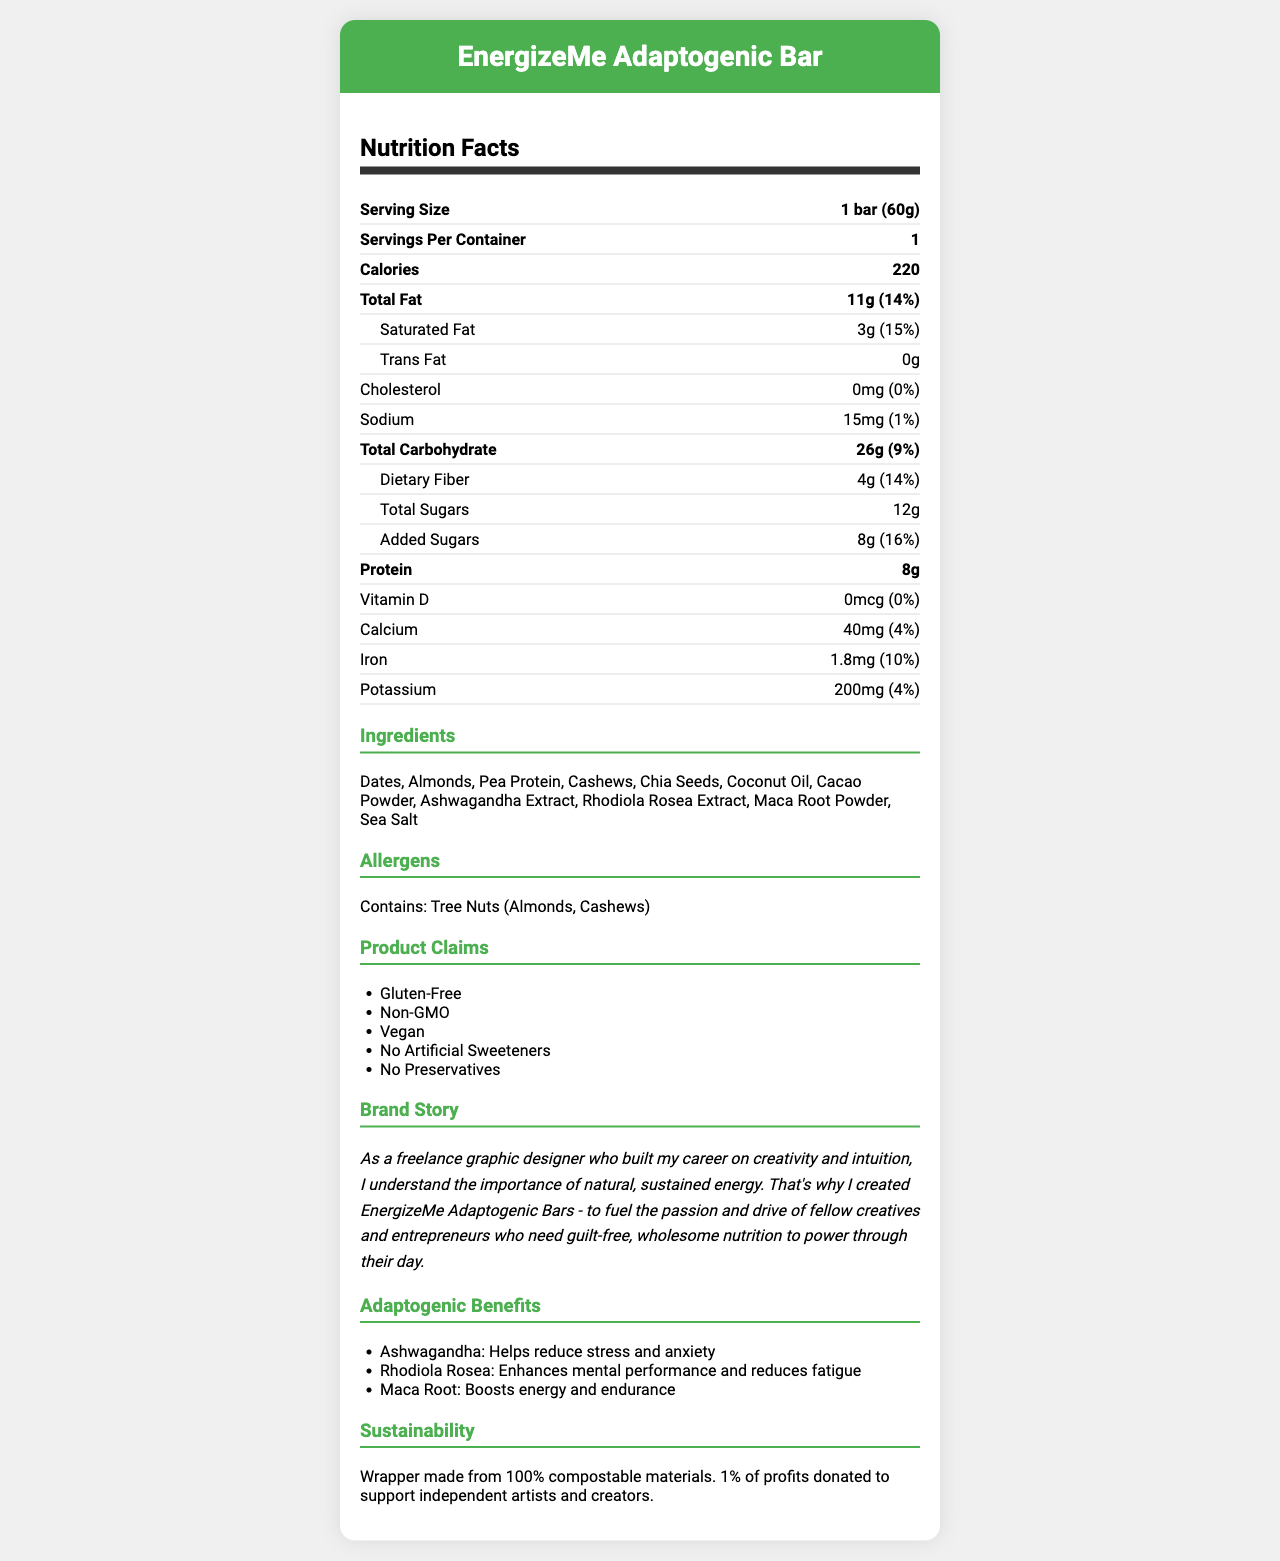what is the serving size for the EnergizeMe Adaptogenic Bar? The serving size is clearly listed as "1 bar (60g)" in the Nutrition Facts section.
Answer: 1 bar (60g) how many calories are in one EnergizeMe Adaptogenic Bar? The Nutrition Facts section lists the calorie content as 220 calories per bar.
Answer: 220 what percentage of the daily value of calcium does the bar provide? The document states that the bar contains 40mg of calcium, which is 4% of the daily value.
Answer: 4% which adaptogen in the bar is known to help reduce stress and anxiety? The Adaptogenic Benefits section states that Ashwagandha helps reduce stress and anxiety.
Answer: Ashwagandha how much added sugar is in the bar? The Nutrition Facts section lists 8g of added sugars with a daily value of 16%.
Answer: 8g what are the main ingredients listed in the bar? The Ingredients section provides this list of all the main ingredients.
Answer: Dates, Almonds, Pea Protein, Cashews, Chia Seeds, Coconut Oil, Cacao Powder, Ashwagandha Extract, Rhodiola Rosea Extract, Maca Root Powder, Sea Salt which of the following is NOT a claim made by the product? A. Gluten-Free B. Organic C. Vegan D. Non-GMO The Claims section lists Gluten-Free, Non-GMO, Vegan, No Artificial Sweeteners, No Preservatives, but not Organic.
Answer: B how much protein does the bar contain? A. 4g B. 6g C. 8g D. 10g The Nutrition Facts section states that the bar contains 8g of protein.
Answer: C is this product safe for someone with a tree nut allergy? The Allergens section specifies that the product contains tree nuts (Almonds, Cashews).
Answer: No summarize the main purpose of the EnergizeMe Adaptogenic Bar based on the document The summary pulls together the information about the product's benefits, target audience, and its key ingredients and features, providing an overview of its purpose and claims.
Answer: The EnergizeMe Adaptogenic Bar is designed to provide natural, guilt-free energy with several adaptogenic ingredients to support mental clarity and endurance. It is aimed at creative professionals and entrepreneurs who value sustained energy without artificial ingredients. The product claims to be Gluten-Free, Non-GMO, Vegan, and contains no artificial sweeteners or preservatives. The packaging supports sustainability by being compostable and part of profits support independent artists and creators. what is the brand's mission related to sustainability? The Sustainability Info section highlights the brand’s commitment to eco-friendly packaging and supporting the creative community.
Answer: Wrapper made from 100% compostable materials. 1% of profits donated to support independent artists and creators. how much iron does the bar contain? The Nutrition Facts section reports that the bar contains 1.8mg of iron, which is 10% of the daily value.
Answer: 1.8mg what percentage of the daily value for dietary fiber does the bar provide? The Nutrition Facts section shows that the bar provides 4g of dietary fiber, which is 14% of the daily value.
Answer: 14% how would you describe the adaptogenic benefits of the ingredients used in the bar? The Adaptogenic Benefits section details these specific benefits associated with each adaptogenic ingredient.
Answer: Ashwagandha helps reduce stress and anxiety, Rhodiola Rosea enhances mental performance and reduces fatigue, Maca Root boosts energy and endurance. which of these ingredients is NOT present in the EnergizeMe Adaptogenic Bar? A. Chia Seeds B. Cacao Powder C. Honey D. Ashwagandha Extract The Ingredients section lists all ingredients and Honey is not included in the list.
Answer: C what is the sodium content of the bar? The Nutrition Facts section indicates that the sodium content is 15mg, which is 1% of the daily value.
Answer: 15mg (1%) does the EnergizeMe Adaptogenic Bar contain cholesterol? The Nutrition Facts section shows 0mg of cholesterol, which equals 0% of the daily value.
Answer: No is the texture of the bar crunchy or chewy? The document does not provide any details about the texture of the bar.
Answer: Not enough information 